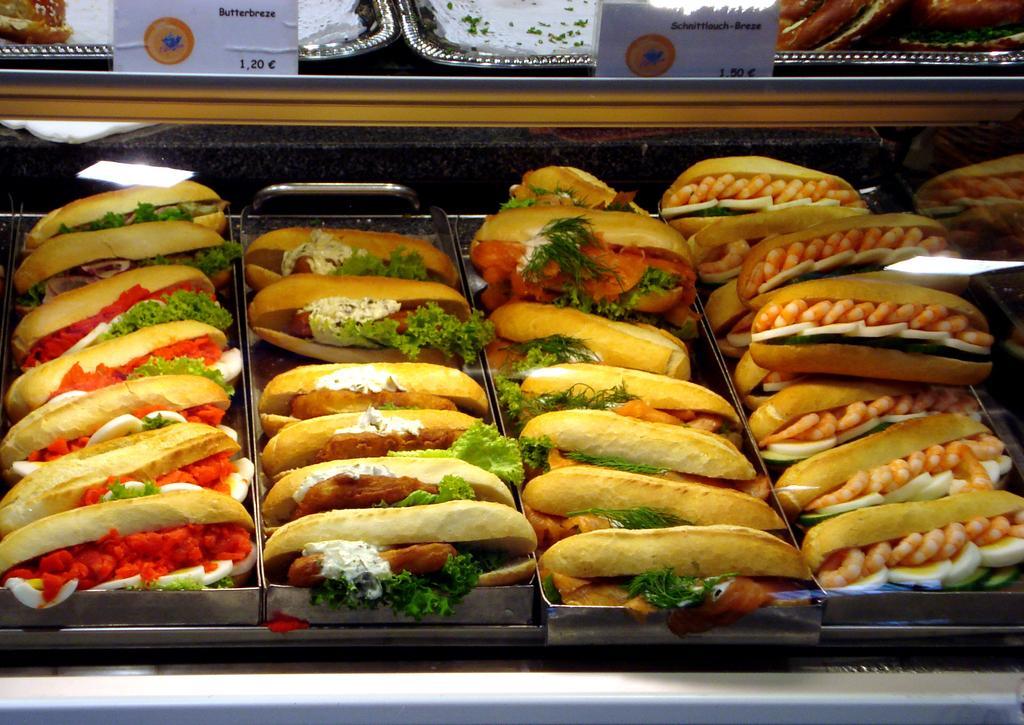How would you summarize this image in a sentence or two? In this image we can see stuffed hot dogs. At the top there are boards. At the bottom there are trays. 